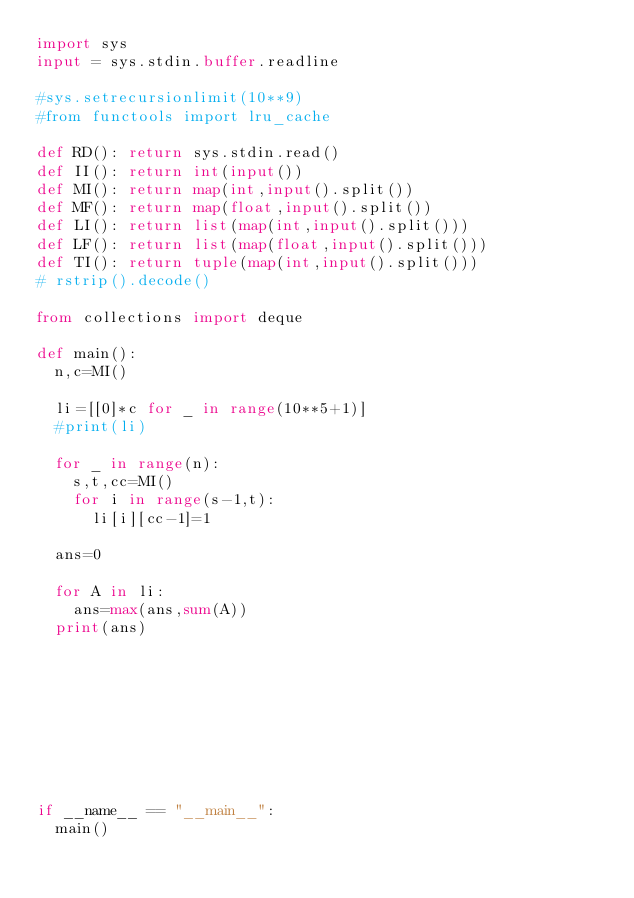<code> <loc_0><loc_0><loc_500><loc_500><_Python_>import sys
input = sys.stdin.buffer.readline

#sys.setrecursionlimit(10**9)
#from functools import lru_cache

def RD(): return sys.stdin.read()
def II(): return int(input())
def MI(): return map(int,input().split())
def MF(): return map(float,input().split())
def LI(): return list(map(int,input().split()))
def LF(): return list(map(float,input().split()))
def TI(): return tuple(map(int,input().split()))
# rstrip().decode()

from collections import deque

def main():
	n,c=MI()

	li=[[0]*c for _ in range(10**5+1)]
	#print(li)

	for _ in range(n):
		s,t,cc=MI()
		for i in range(s-1,t):
			li[i][cc-1]=1

	ans=0

	for A in li:
		ans=max(ans,sum(A))
	print(ans)









if __name__ == "__main__":
	main()
</code> 